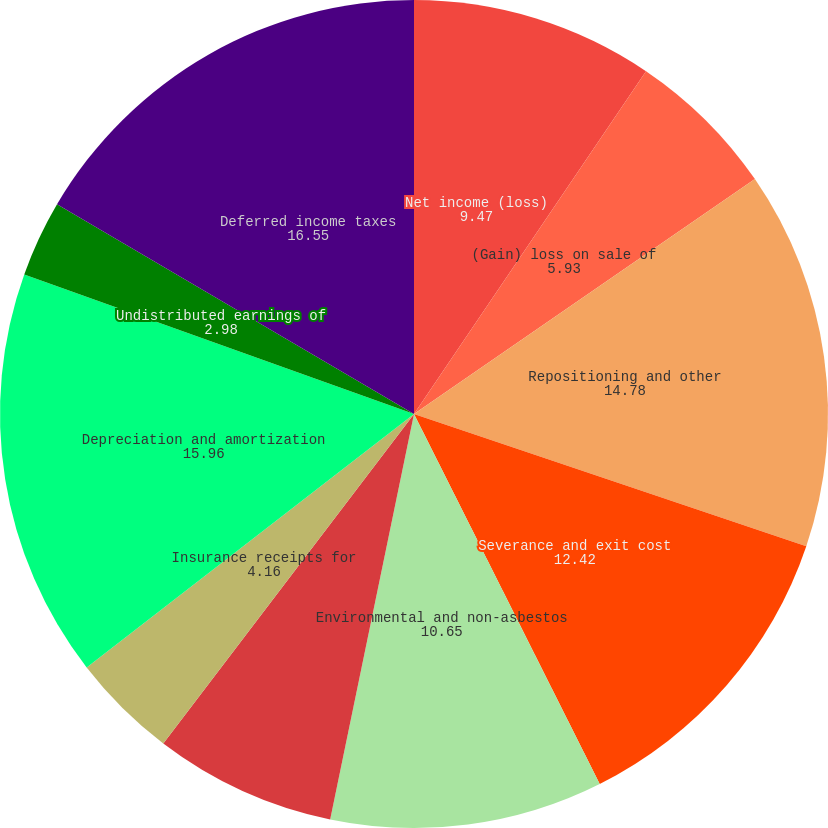Convert chart to OTSL. <chart><loc_0><loc_0><loc_500><loc_500><pie_chart><fcel>Net income (loss)<fcel>(Gain) loss on sale of<fcel>Repositioning and other<fcel>Severance and exit cost<fcel>Environmental and non-asbestos<fcel>Asbestos related liability<fcel>Insurance receipts for<fcel>Depreciation and amortization<fcel>Undistributed earnings of<fcel>Deferred income taxes<nl><fcel>9.47%<fcel>5.93%<fcel>14.78%<fcel>12.42%<fcel>10.65%<fcel>7.11%<fcel>4.16%<fcel>15.96%<fcel>2.98%<fcel>16.55%<nl></chart> 